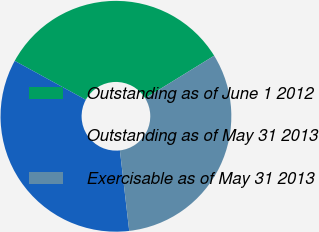Convert chart. <chart><loc_0><loc_0><loc_500><loc_500><pie_chart><fcel>Outstanding as of June 1 2012<fcel>Outstanding as of May 31 2013<fcel>Exercisable as of May 31 2013<nl><fcel>33.23%<fcel>34.81%<fcel>31.96%<nl></chart> 